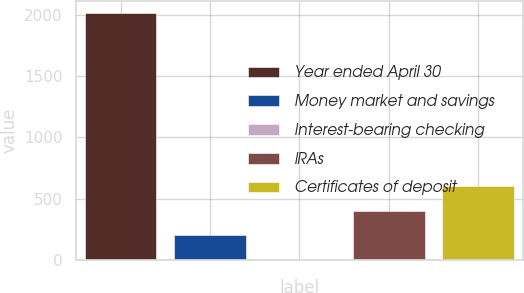Convert chart. <chart><loc_0><loc_0><loc_500><loc_500><bar_chart><fcel>Year ended April 30<fcel>Money market and savings<fcel>Interest-bearing checking<fcel>IRAs<fcel>Certificates of deposit<nl><fcel>2012<fcel>201.44<fcel>0.27<fcel>402.61<fcel>603.78<nl></chart> 